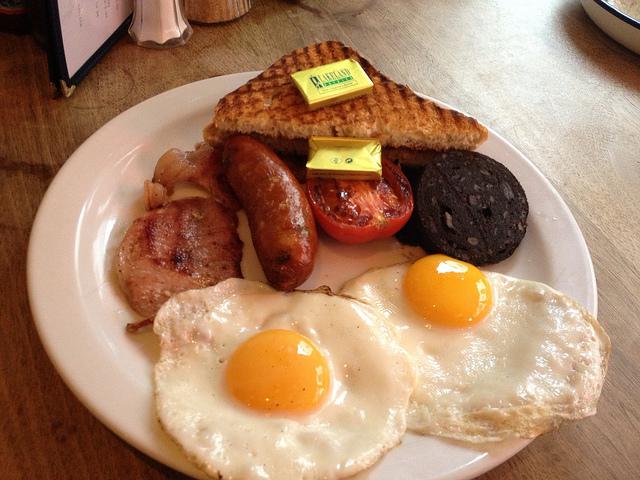How many doughnut holes can you see in this picture?
Answer briefly. 0. What are the dark brown things next to the tomato?
Be succinct. Sausage. How many eggs are on this plate?
Short answer required. 2. How many foil butter is on the plate?
Be succinct. 2. 